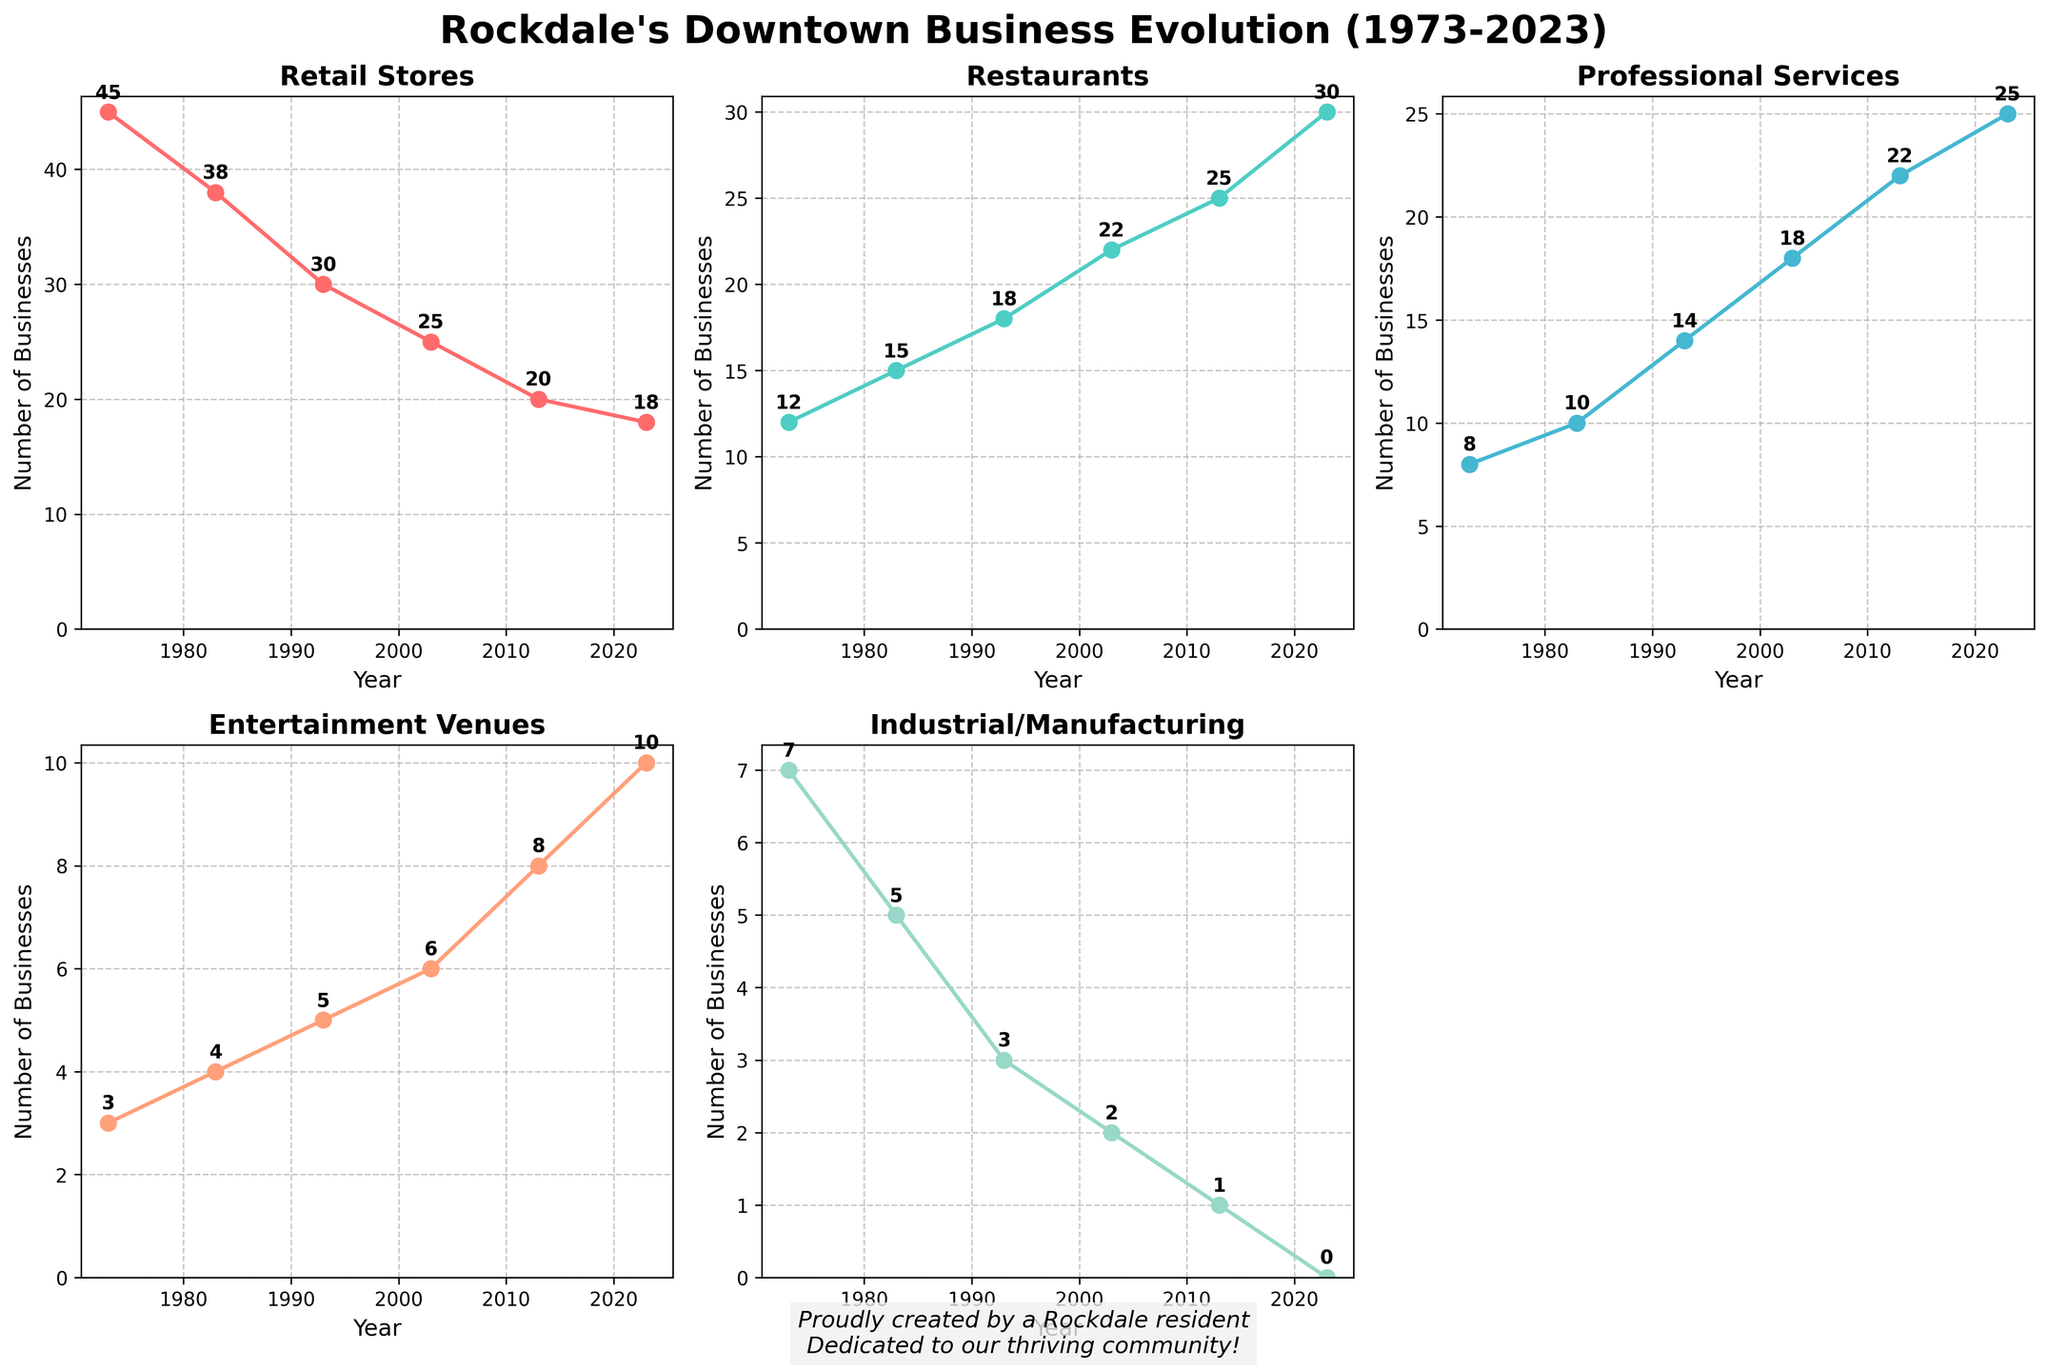How many business categories are displayed in the figure? There are five plots, each representing a different business category, namely Retail Stores, Restaurants, Professional Services, Entertainment Venues, and Industrial/Manufacturing. This total number of categories present is five.
Answer: Five What is the general trend for Retail Stores over the years? From 1973 to 2023, the number of Retail Stores has consistently decreased, starting from 45 in 1973 and dropping to 18 in 2023. This indicates a declining trend.
Answer: Decreasing Which category had the highest number of businesses in 2023? In the subplot for 2023, Restaurants have the highest number, with 30 businesses. This is more than any other category for the same year.
Answer: Restaurants What is the difference in the number of Entertainment Venues between 1973 and 2023? Looking at the points for Entertainment Venues in 1973 and 2023 gives 3 and 10, respectively. Subtracting the number in 1973 from the number in 2023 results in a difference of 7 (10 - 3).
Answer: 7 How did the number of Professional Services change from 1983 to 2023? In 1983, there were 10 Professional Services. By 2023, this number increased to 25. This shows an increase of 15 over the 40-year period (25 - 10).
Answer: Increased by 15 Which business category declined to zero by 2023? Observing the number of businesses over the years, the Industrial/Manufacturing category decreases to zero in 2023. This indicates it no longer exists in the downtown area by that year.
Answer: Industrial/Manufacturing In what year did Restaurants surpass Retail Stores in number? Comparing the trends, Restaurants surpassed Retail Stores between 2003 and 2013. Specifically, in 2013, Restaurants had 25 while Retail Stores had 20, so the surpassing occurred by 2013.
Answer: 2013 What are the changes in the number of Restaurants from 1973 to 2023? Beginning at 12 restaurants in 1973, the number increased to 30 by 2023. This is an increase of 18 over the 50 years (30 - 12).
Answer: Increased by 18 